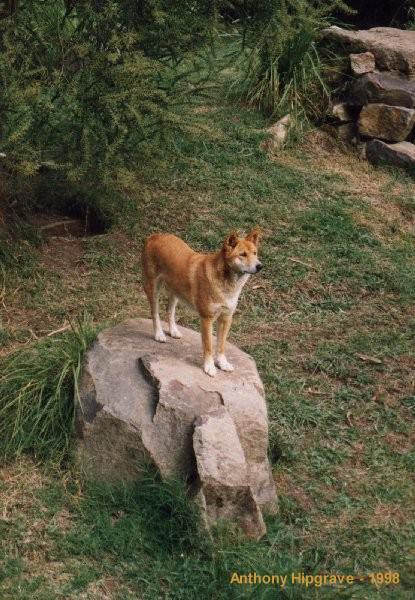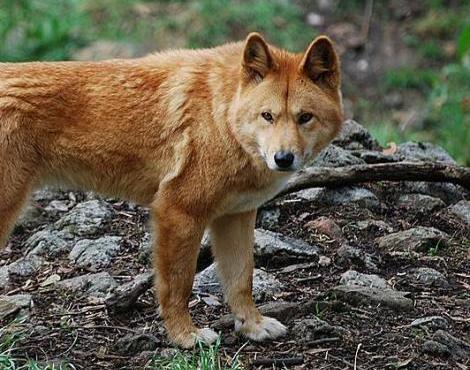The first image is the image on the left, the second image is the image on the right. For the images shown, is this caption "The left image contains at least two dingos." true? Answer yes or no. No. The first image is the image on the left, the second image is the image on the right. Analyze the images presented: Is the assertion "There are two animals in total." valid? Answer yes or no. Yes. 